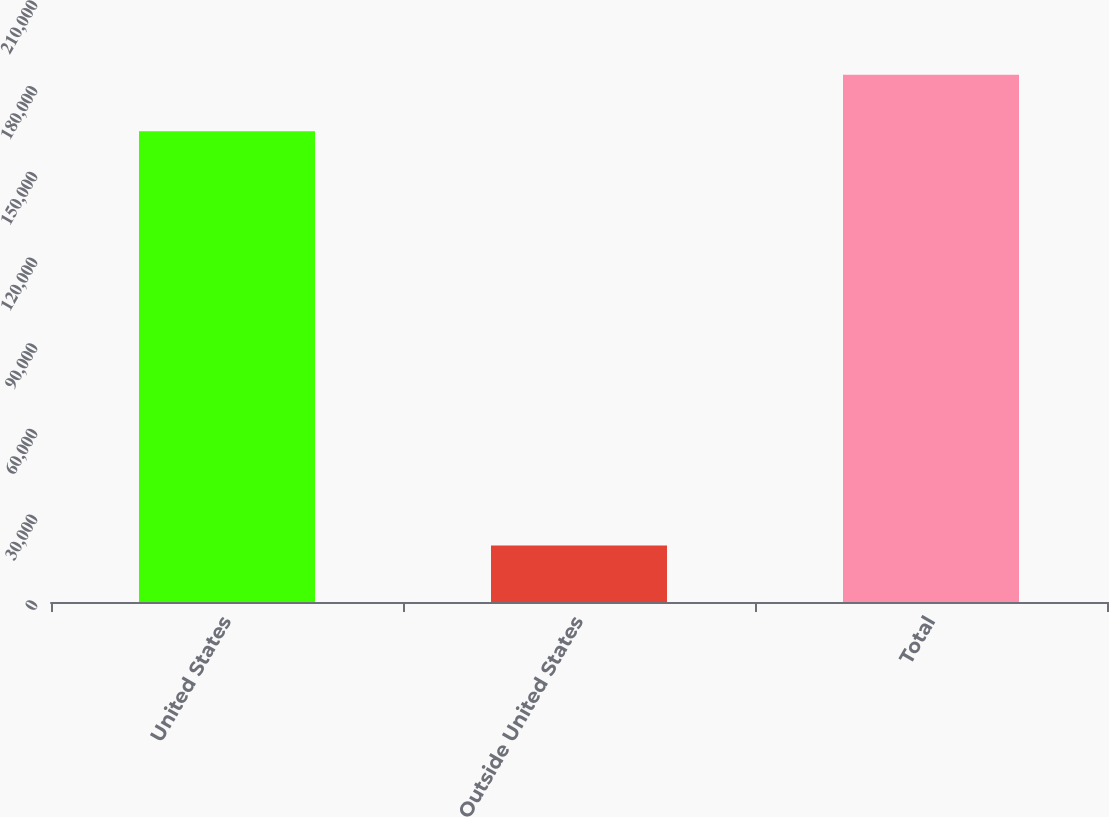Convert chart to OTSL. <chart><loc_0><loc_0><loc_500><loc_500><bar_chart><fcel>United States<fcel>Outside United States<fcel>Total<nl><fcel>164784<fcel>19764<fcel>184548<nl></chart> 